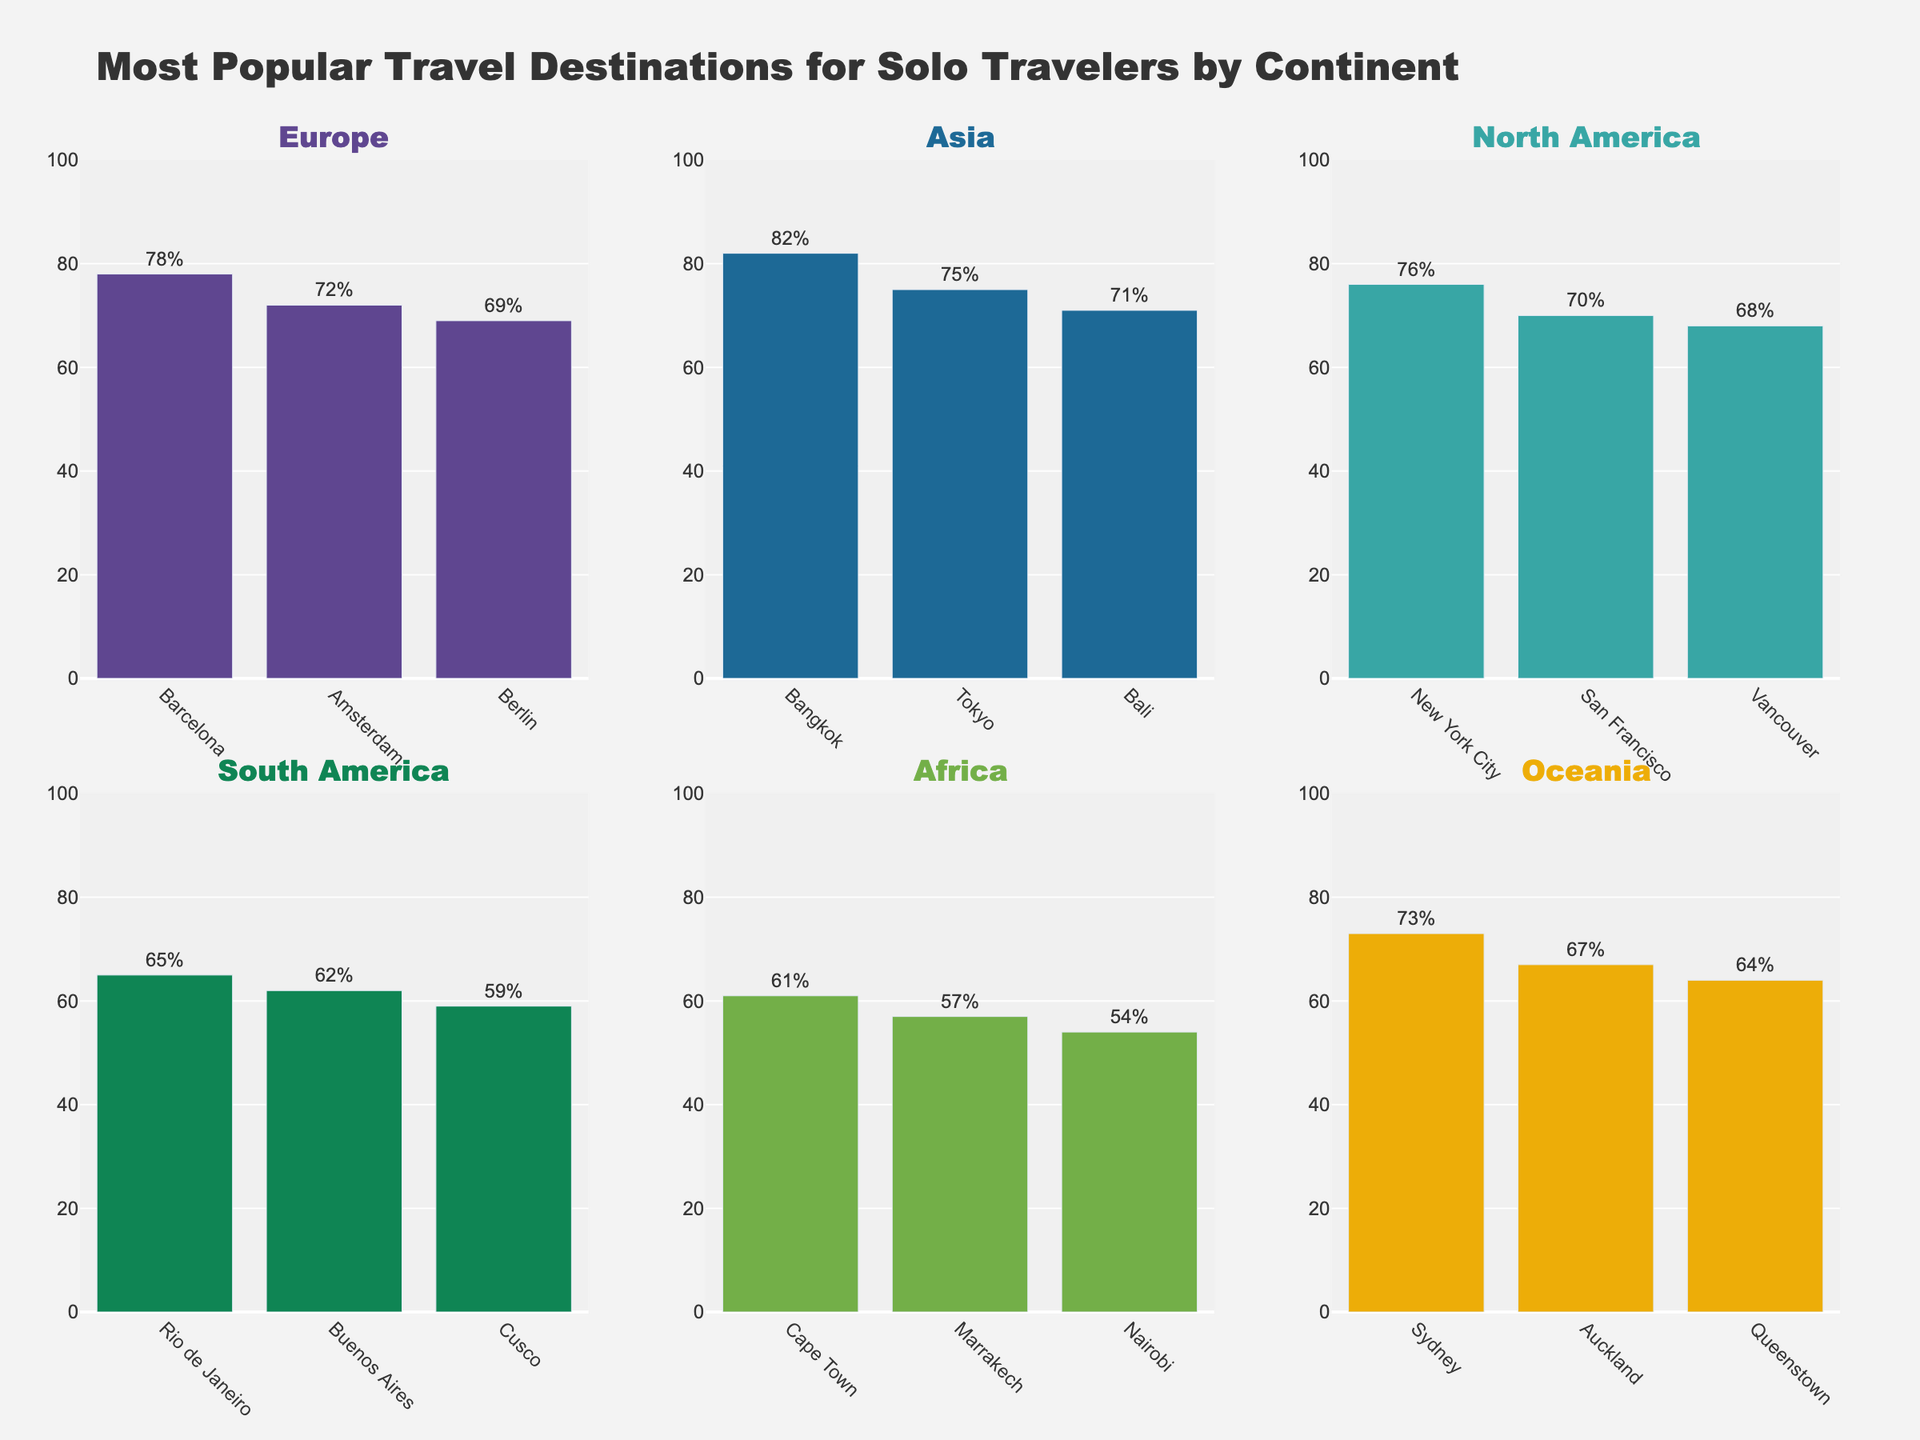Which destination in Europe has the highest popularity among solo travelers? The bar for Barcelona in Europe has the highest value among other European destinations, reaching 78%.
Answer: Barcelona What's the sum of the popularity percentages for the most popular destinations in each continent? Summing up the highest popularity values for each continent: Europe (Barcelona 78%), Asia (Bangkok 82%), North America (New York City 76%), South America (Rio de Janeiro 65%), Africa (Cape Town 61%), Oceania (Sydney 73%). The sum is 78 + 82 + 76 + 65 + 61 + 73 = 435.
Answer: 435 Which continent has both the highest and lowest solo travel popularities? The highest bar overall is Bangkok in Asia with 82%, and the lowest bar overall is Nairobi in Africa with 54%. Therefore, Asia has the highest, and Africa has the lowest numbers.
Answer: Asia, Africa Among the top three destinations in Oceania, which one is least popular? The bars in Oceania show Sydney at 73%, Auckland at 67%, and Queenstown at 64%. Queenstown has the lowest popularity among them.
Answer: Queenstown Compare the popularity of Tokyo and Sydney. Which is more popular and by how much? The bar of Tokyo in Asia is 75%, and the bar of Sydney in Oceania is 73%. Tokyo is more popular than Sydney by 2 percentage points (75% - 73% = 2).
Answer: Tokyo by 2% What is the difference in popularity between the least popular destination in Europe and the most popular destination in South America? The least popular destination in Europe is Berlin at 69%, and the most popular in South America is Rio de Janeiro at 65%. The difference is 69% - 65% = 4%.
Answer: 4% Which destination in North America has the lowest solo traveler popularity? The bars in North America show New York City (76%), San Francisco (70%), and Vancouver (68%). Vancouver has the lowest popularity among them.
Answer: Vancouver What are the combined popularity percentages of destinations in Africa? Summing up the values in Africa: Cape Town (61%), Marrakech (57%), and Nairobi (54%). The sum is 61 + 57 + 54 = 172.
Answer: 172 How does the popularity of Amsterdam compare to New York City? The bar for Amsterdam in Europe is 72%, and the bar for New York City in North America is 76%. New York City is more popular by 4 percentage points (76% - 72% = 4).
Answer: New York City by 4% What is the average popularity of Asian destinations? The bars in Asia show Bangkok (82%), Tokyo (75%), and Bali (71%). Summing these values gives 82 + 75 + 71 = 228, and the average is 228 / 3 = 76.
Answer: 76 